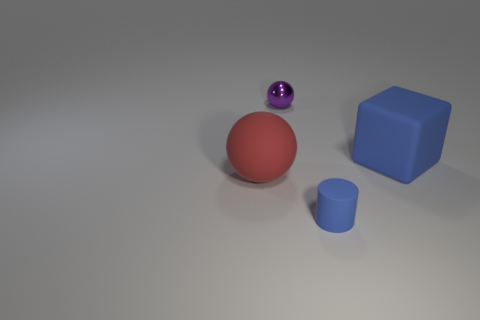Is the color of the rubber thing in front of the big red object the same as the big matte object that is right of the tiny cylinder?
Give a very brief answer. Yes. There is a thing that is the same color as the block; what material is it?
Give a very brief answer. Rubber. Are there any large cyan matte objects?
Keep it short and to the point. No. Are there the same number of spheres that are behind the matte sphere and large blue cubes?
Your answer should be very brief. Yes. Is there anything else that is the same material as the purple ball?
Your answer should be compact. No. How many big objects are either blue rubber cubes or gray things?
Ensure brevity in your answer.  1. There is a thing that is the same color as the large cube; what is its shape?
Make the answer very short. Cylinder. Do the sphere right of the large red sphere and the tiny blue object have the same material?
Provide a short and direct response. No. There is a big object to the right of the large rubber thing that is to the left of the cylinder; what is it made of?
Keep it short and to the point. Rubber. What number of other red objects have the same shape as the small shiny object?
Offer a terse response. 1. 